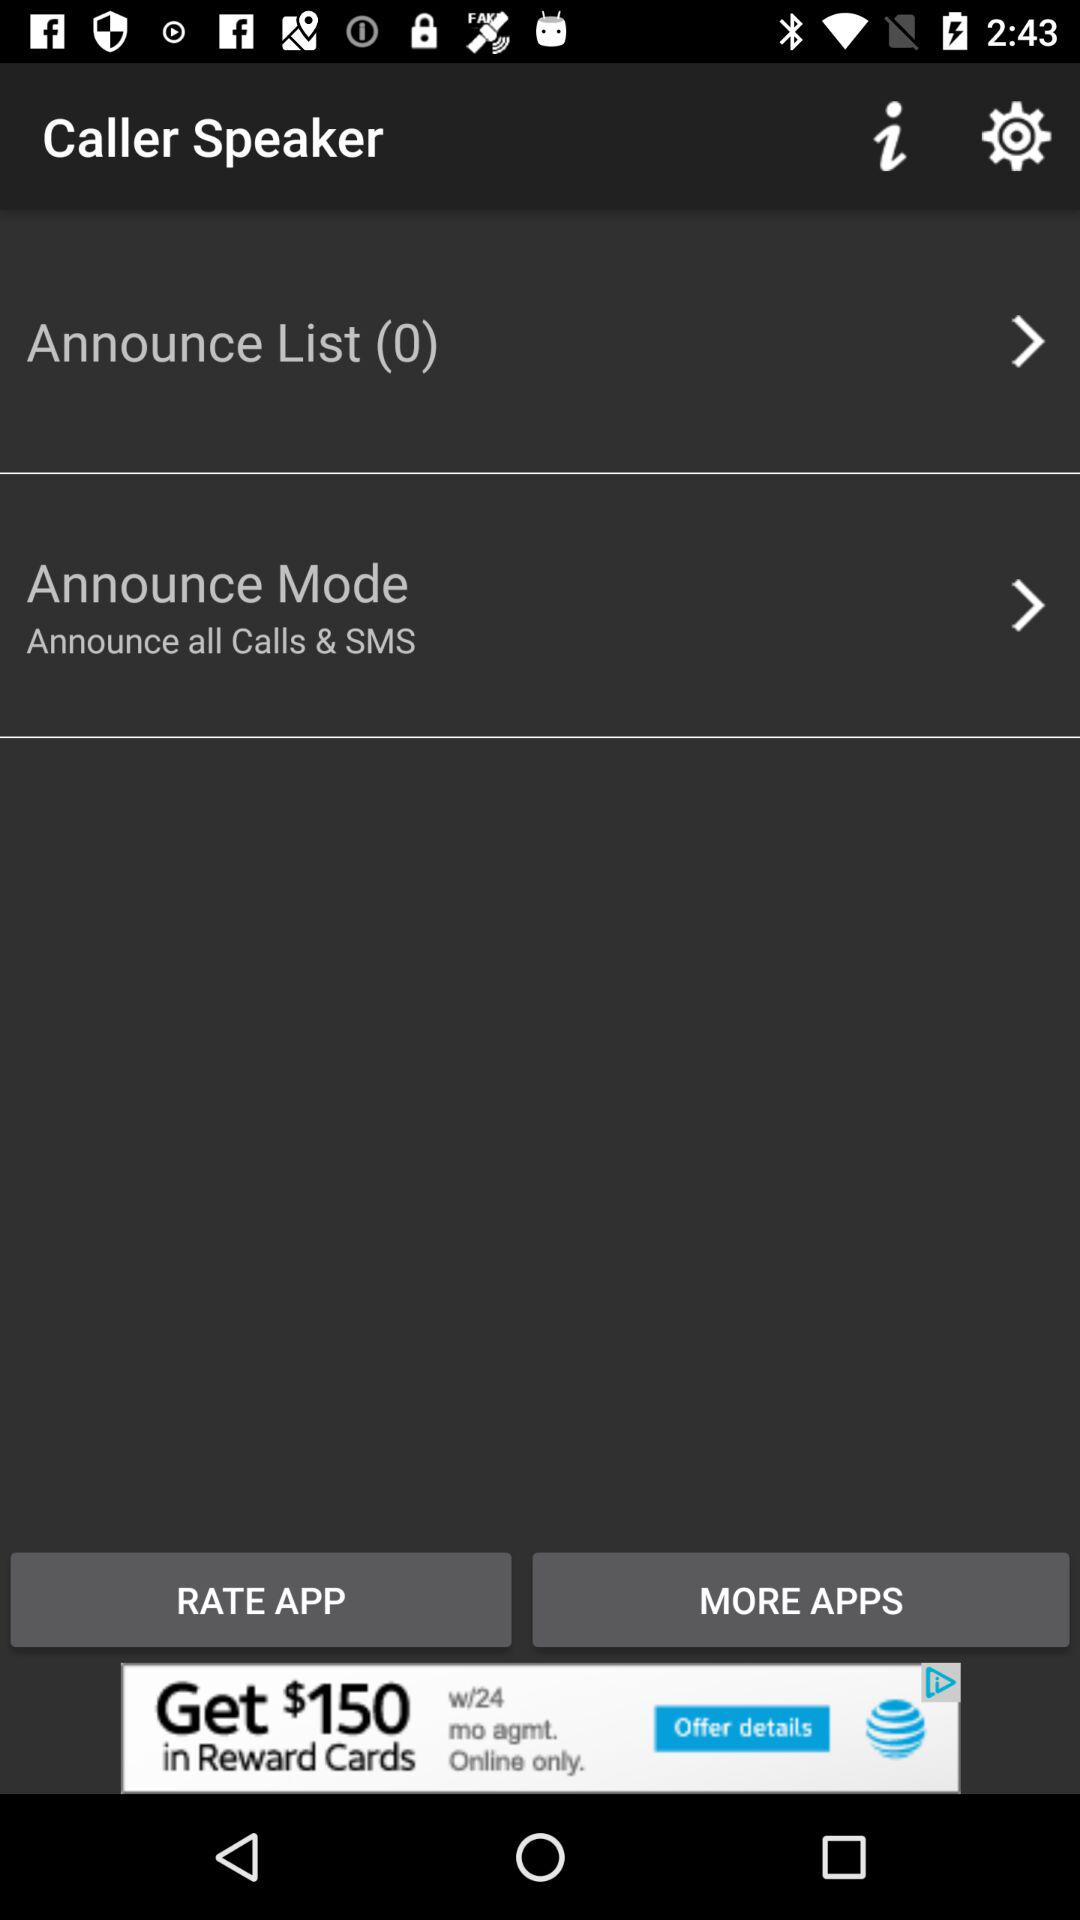What is the application name? The application name is "Caller Speaker". 